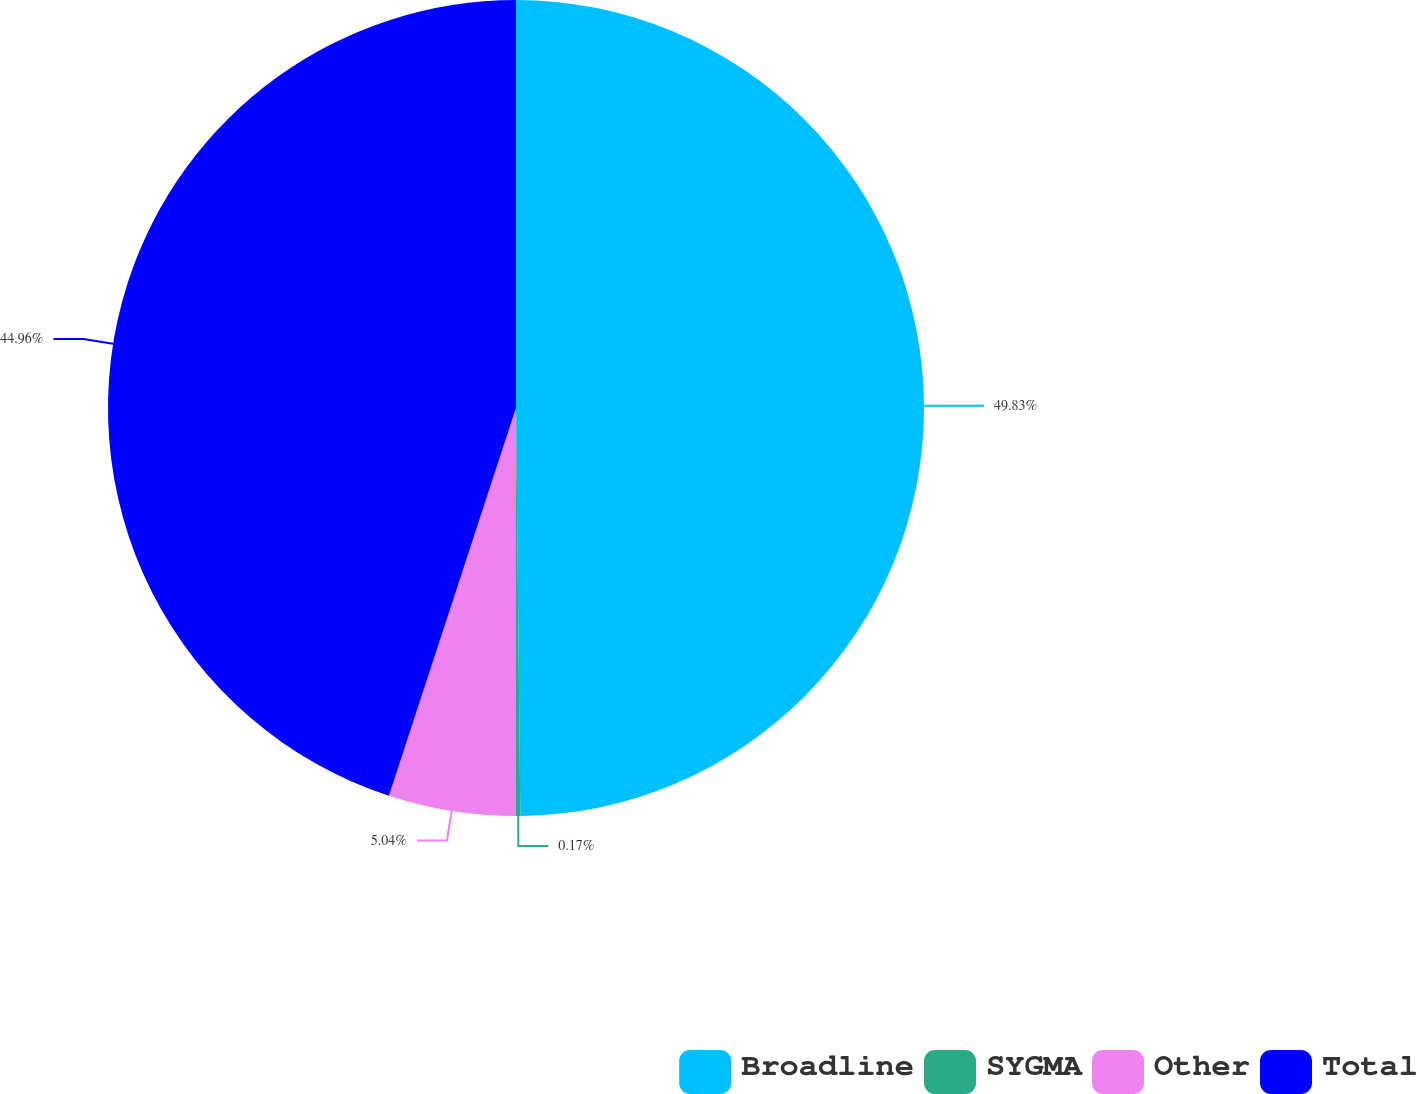<chart> <loc_0><loc_0><loc_500><loc_500><pie_chart><fcel>Broadline<fcel>SYGMA<fcel>Other<fcel>Total<nl><fcel>49.83%<fcel>0.17%<fcel>5.04%<fcel>44.96%<nl></chart> 